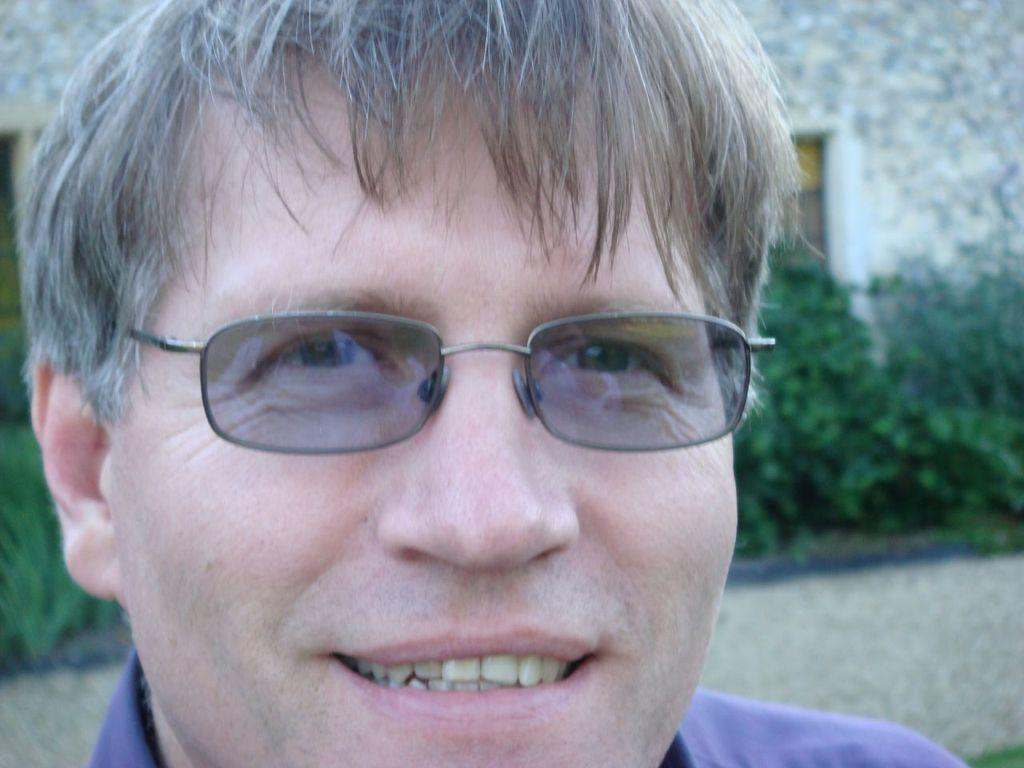Who is present in the image? There is a man in the image. What is the man doing in the image? The man is smiling in the image. What accessory is the man wearing? The man is wearing spectacles in the image. What can be seen in the background of the image? There is a wall and plants in the background of the image. What type of record is the man holding in the image? There is no record present in the image. 